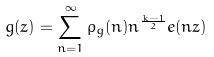<formula> <loc_0><loc_0><loc_500><loc_500>g ( z ) = \sum _ { n = 1 } ^ { \infty } \rho _ { g } ( n ) n ^ { \frac { k - 1 } { 2 } } e ( n z )</formula> 